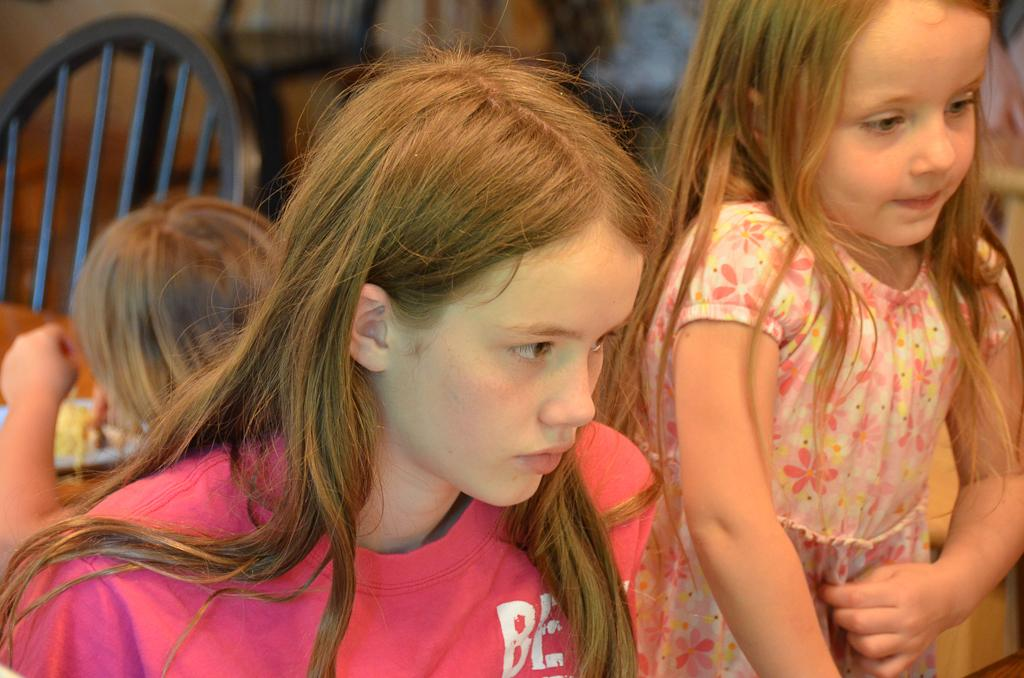Who is the main subject in the image? There is a girl in the image. Are there any other people in the image? Yes, there are kids in the image. What can be seen in the background of the image? There are chairs and objects on a table in the background of the image. Can you see a blade in the girl's hand in the image? No, there is no blade present in the image. Is there an ocean visible in the background of the image? No, there is no ocean present in the image. 